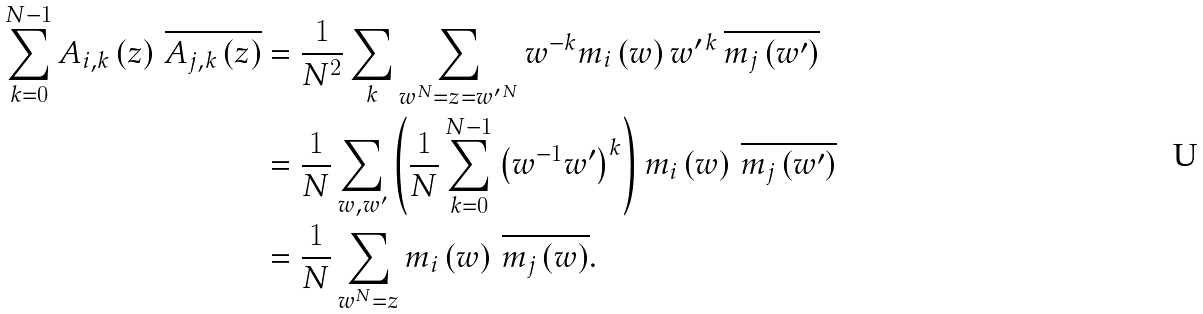<formula> <loc_0><loc_0><loc_500><loc_500>\sum _ { k = 0 } ^ { N - 1 } A _ { i , k } \left ( z \right ) \, \overline { A _ { j , k } \left ( z \right ) } & = \frac { 1 } { N ^ { 2 } } \sum _ { k } \sum _ { w ^ { N } = z = w ^ { \prime \, N } } w ^ { - k } m _ { i } \left ( w \right ) w ^ { \prime \, k } \, \overline { m _ { j } \left ( w ^ { \prime } \right ) } \\ & = \frac { 1 } { N } \sum _ { w , w ^ { \prime } } \left ( \frac { 1 } { N } \sum _ { k = 0 } ^ { N - 1 } \left ( w ^ { - 1 } w ^ { \prime } \right ) ^ { k } \right ) m _ { i } \left ( w \right ) \, \overline { m _ { j } \left ( w ^ { \prime } \right ) } \\ & = \frac { 1 } { N } \sum _ { w ^ { N } = z } m _ { i } \left ( w \right ) \, \overline { m _ { j } \left ( w \right ) } .</formula> 